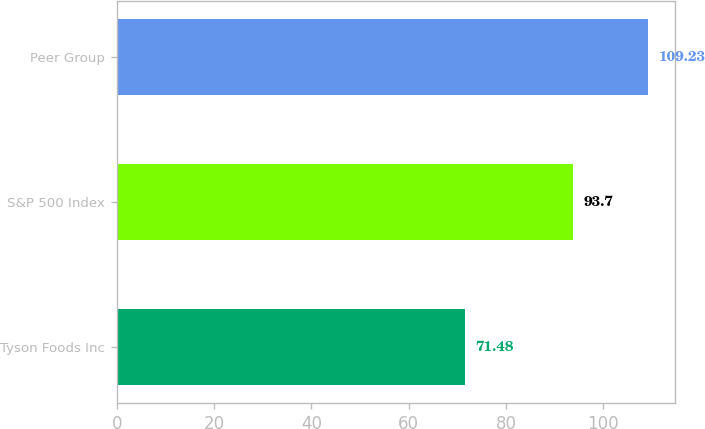<chart> <loc_0><loc_0><loc_500><loc_500><bar_chart><fcel>Tyson Foods Inc<fcel>S&P 500 Index<fcel>Peer Group<nl><fcel>71.48<fcel>93.7<fcel>109.23<nl></chart> 